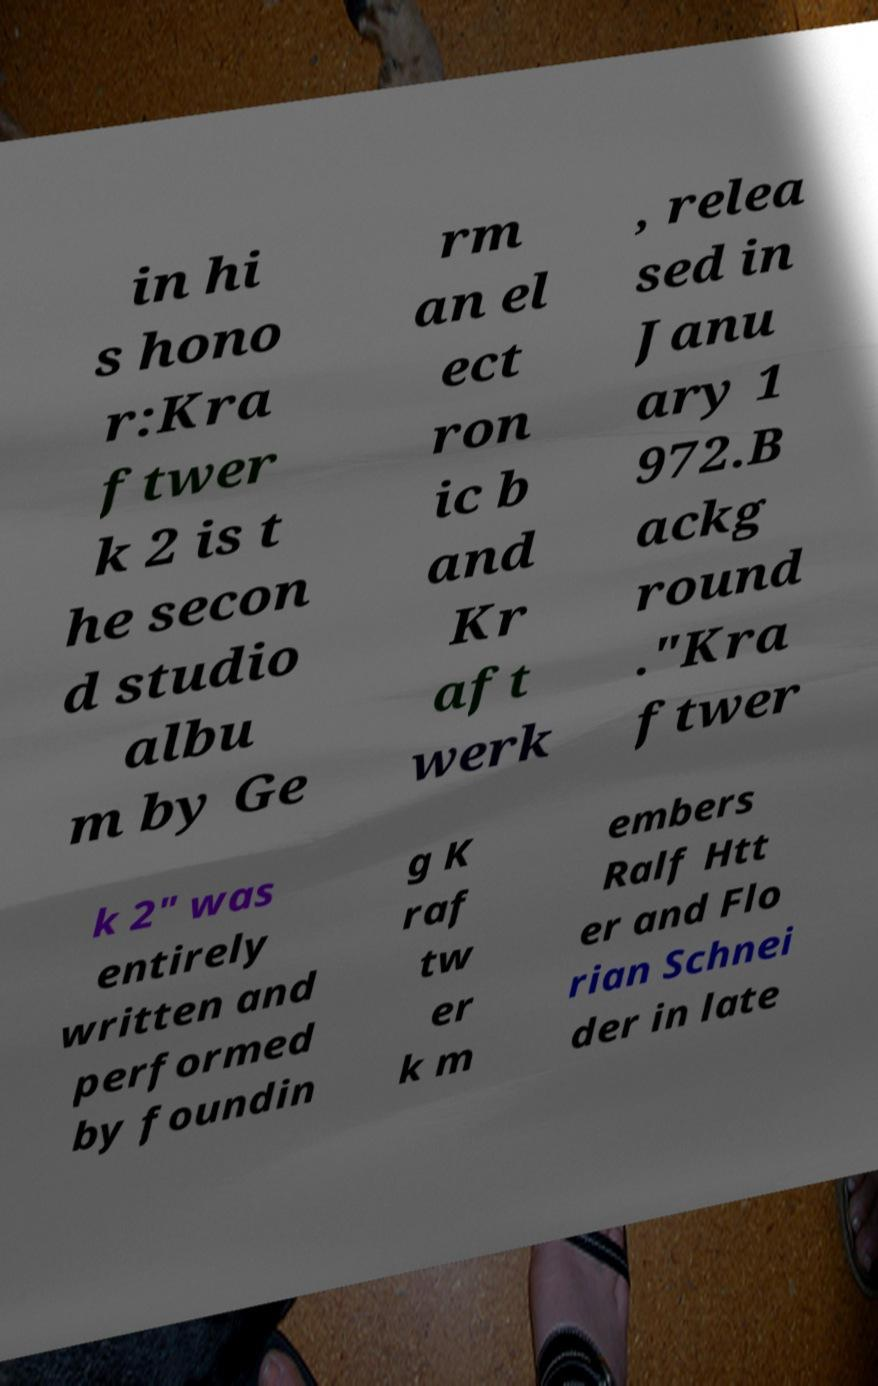For documentation purposes, I need the text within this image transcribed. Could you provide that? in hi s hono r:Kra ftwer k 2 is t he secon d studio albu m by Ge rm an el ect ron ic b and Kr aft werk , relea sed in Janu ary 1 972.B ackg round ."Kra ftwer k 2" was entirely written and performed by foundin g K raf tw er k m embers Ralf Htt er and Flo rian Schnei der in late 